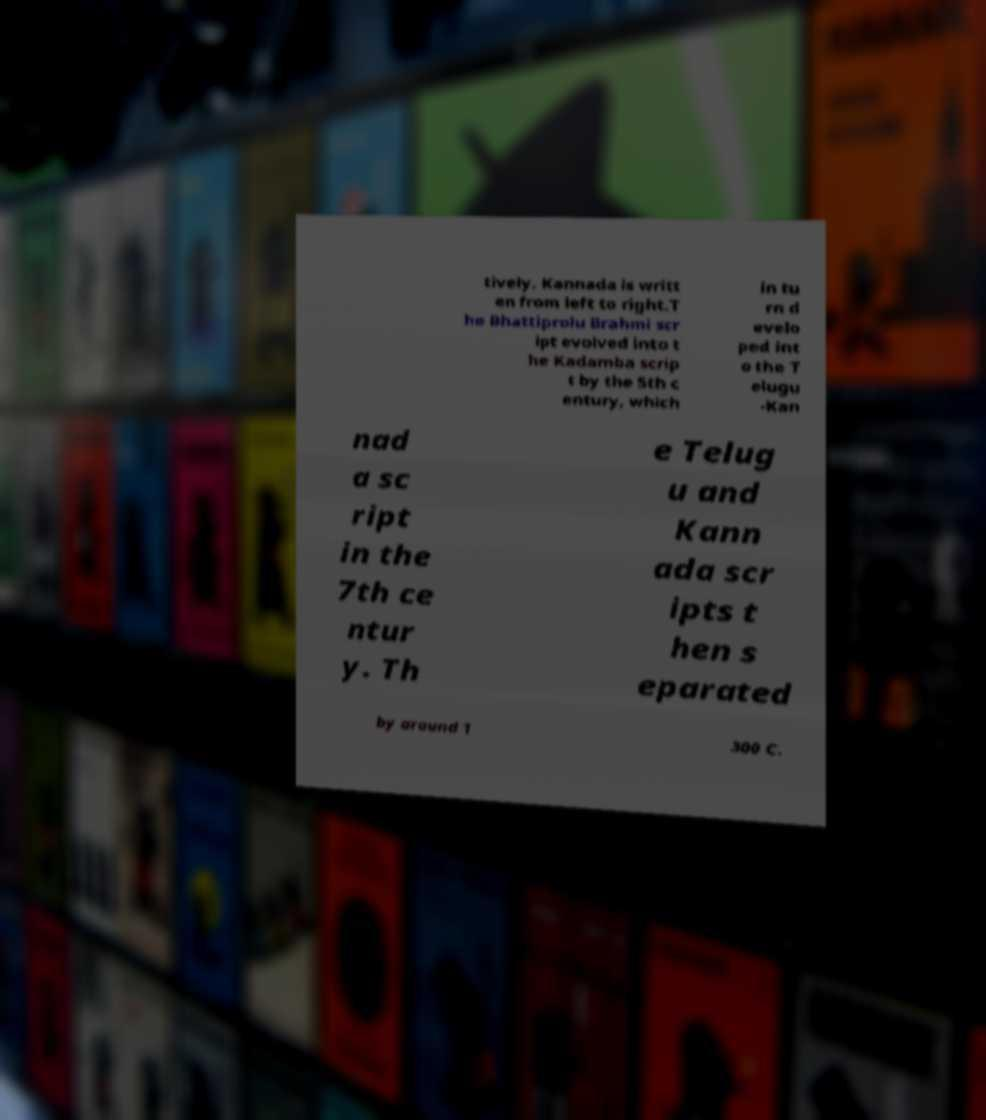There's text embedded in this image that I need extracted. Can you transcribe it verbatim? tively. Kannada is writt en from left to right.T he Bhattiprolu Brahmi scr ipt evolved into t he Kadamba scrip t by the 5th c entury, which in tu rn d evelo ped int o the T elugu -Kan nad a sc ript in the 7th ce ntur y. Th e Telug u and Kann ada scr ipts t hen s eparated by around 1 300 C. 